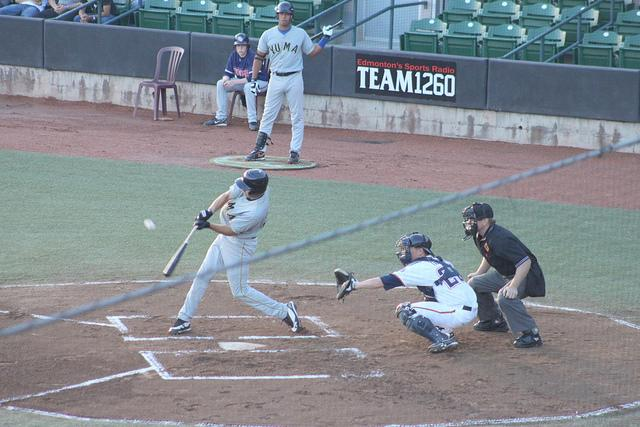What province is this located?

Choices:
A) ontario
B) alberta
C) pei
D) bc alberta 